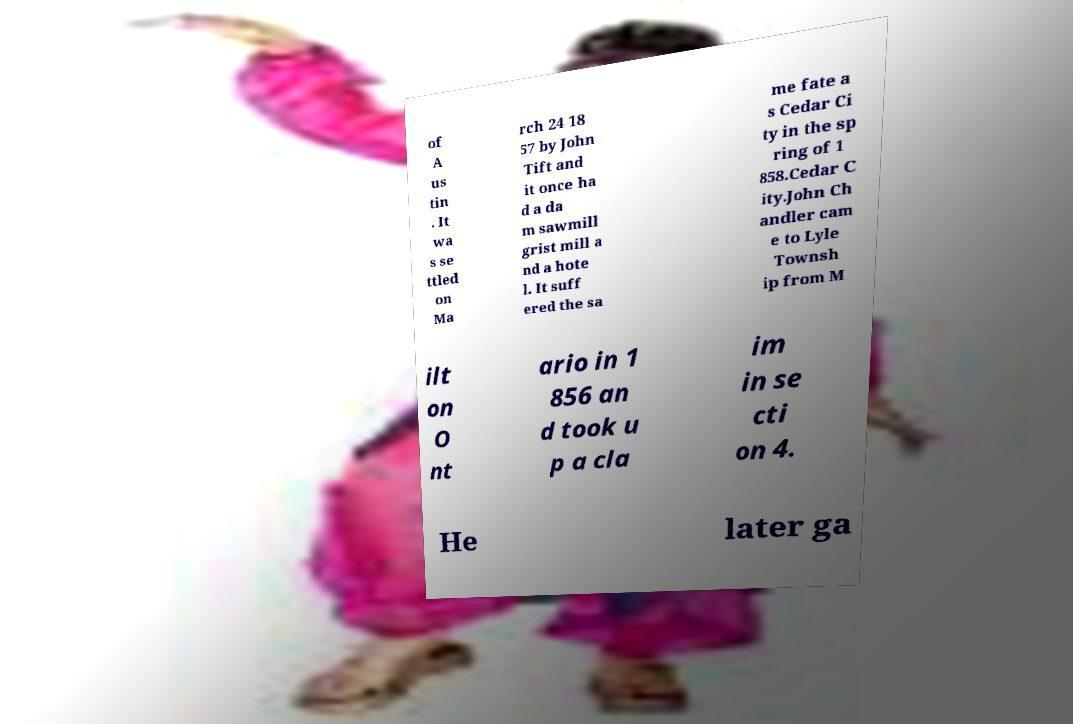For documentation purposes, I need the text within this image transcribed. Could you provide that? of A us tin . It wa s se ttled on Ma rch 24 18 57 by John Tift and it once ha d a da m sawmill grist mill a nd a hote l. It suff ered the sa me fate a s Cedar Ci ty in the sp ring of 1 858.Cedar C ity.John Ch andler cam e to Lyle Townsh ip from M ilt on O nt ario in 1 856 an d took u p a cla im in se cti on 4. He later ga 